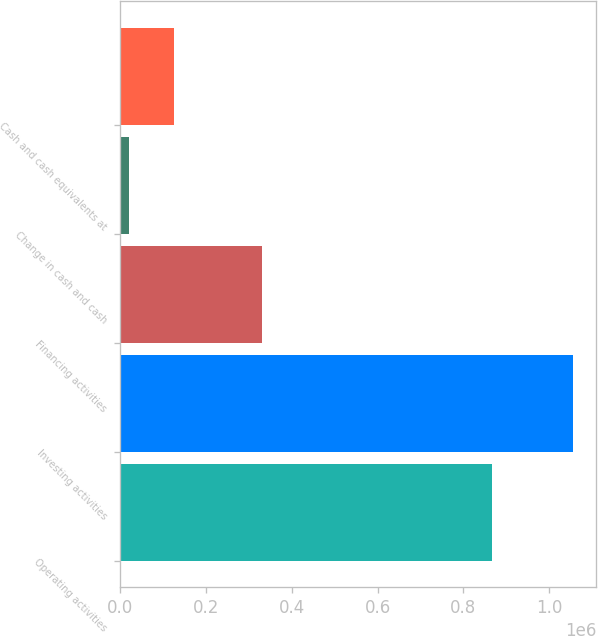Convert chart. <chart><loc_0><loc_0><loc_500><loc_500><bar_chart><fcel>Operating activities<fcel>Investing activities<fcel>Financing activities<fcel>Change in cash and cash<fcel>Cash and cash equivalents at<nl><fcel>867090<fcel>1.05631e+06<fcel>331679<fcel>21125<fcel>124643<nl></chart> 